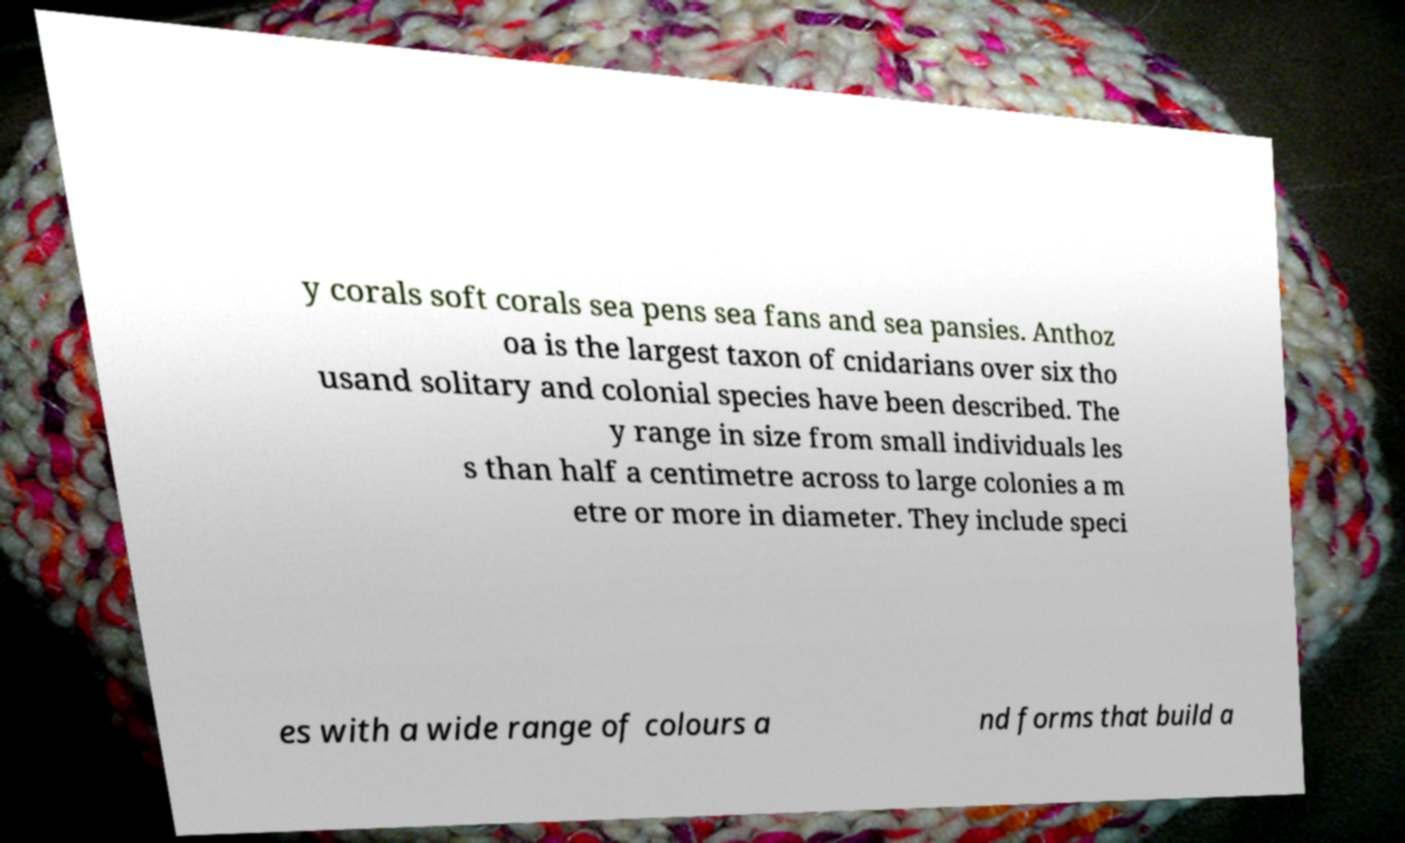Please identify and transcribe the text found in this image. y corals soft corals sea pens sea fans and sea pansies. Anthoz oa is the largest taxon of cnidarians over six tho usand solitary and colonial species have been described. The y range in size from small individuals les s than half a centimetre across to large colonies a m etre or more in diameter. They include speci es with a wide range of colours a nd forms that build a 